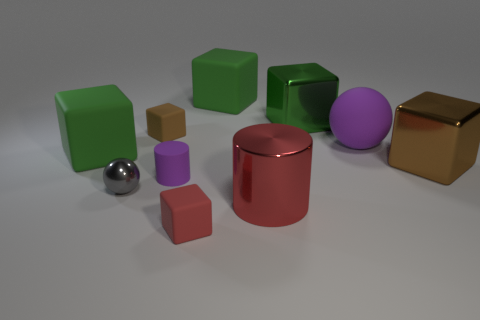Does the big block behind the big green shiny cube have the same material as the green object on the left side of the matte cylinder?
Ensure brevity in your answer.  Yes. How many objects are big things that are left of the green metal block or big yellow spheres?
Ensure brevity in your answer.  3. Is the number of red matte cubes right of the red rubber thing less than the number of brown matte things on the right side of the large brown cube?
Make the answer very short. No. How many other objects are the same size as the red cylinder?
Provide a short and direct response. 5. Is the big ball made of the same material as the brown thing that is right of the small purple object?
Give a very brief answer. No. What number of objects are either tiny purple matte objects behind the small gray shiny ball or large cubes that are on the left side of the large purple rubber sphere?
Keep it short and to the point. 4. The small cylinder has what color?
Make the answer very short. Purple. Is the number of big red metal cylinders right of the brown metal thing less than the number of tiny metallic balls?
Provide a succinct answer. Yes. Is there any other thing that has the same shape as the large brown thing?
Make the answer very short. Yes. Is there a big green rubber cube?
Provide a short and direct response. Yes. 